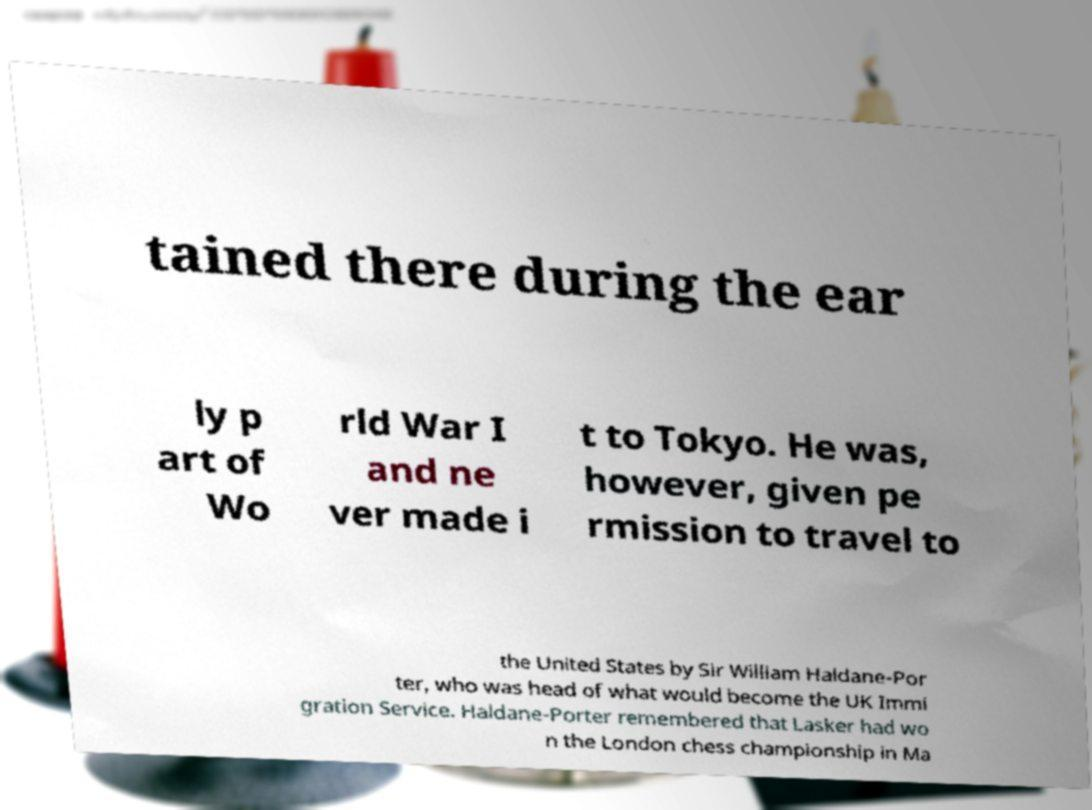Could you extract and type out the text from this image? tained there during the ear ly p art of Wo rld War I and ne ver made i t to Tokyo. He was, however, given pe rmission to travel to the United States by Sir William Haldane-Por ter, who was head of what would become the UK Immi gration Service. Haldane-Porter remembered that Lasker had wo n the London chess championship in Ma 